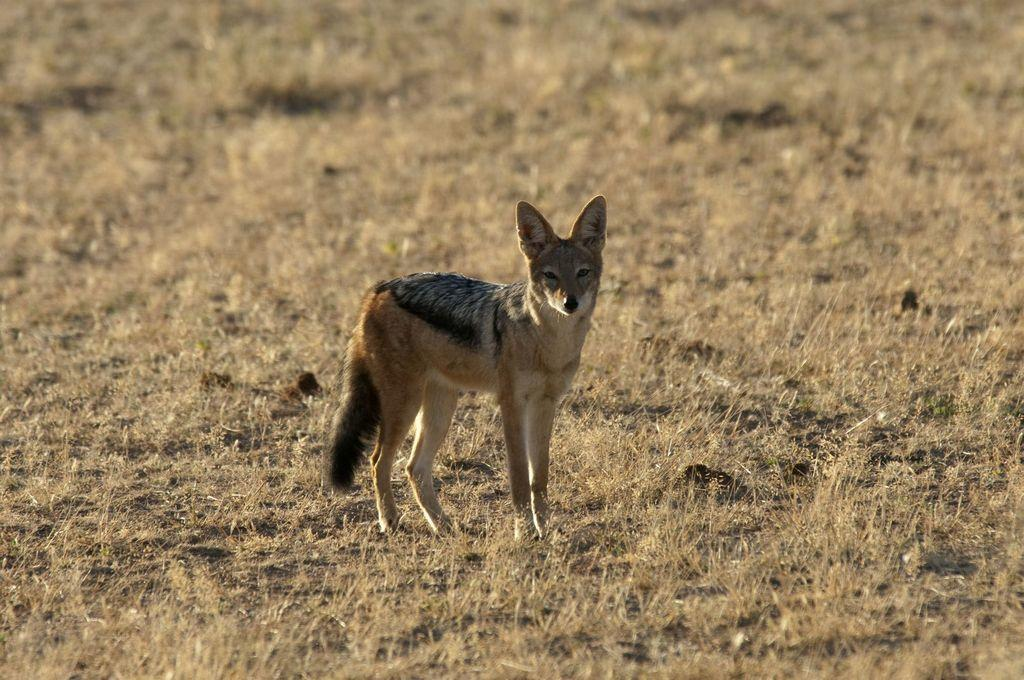What animal is present in the image? There is a fox in the image. What is the fox standing on? The fox is standing on dry grass. What type of hair is visible on the fox in the image? There is no mention of hair in the provided facts, and the image does not show any visible hair on the fox. 